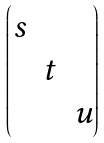Convert formula to latex. <formula><loc_0><loc_0><loc_500><loc_500>\begin{pmatrix} s & & \\ & t & \\ & & u \end{pmatrix}</formula> 